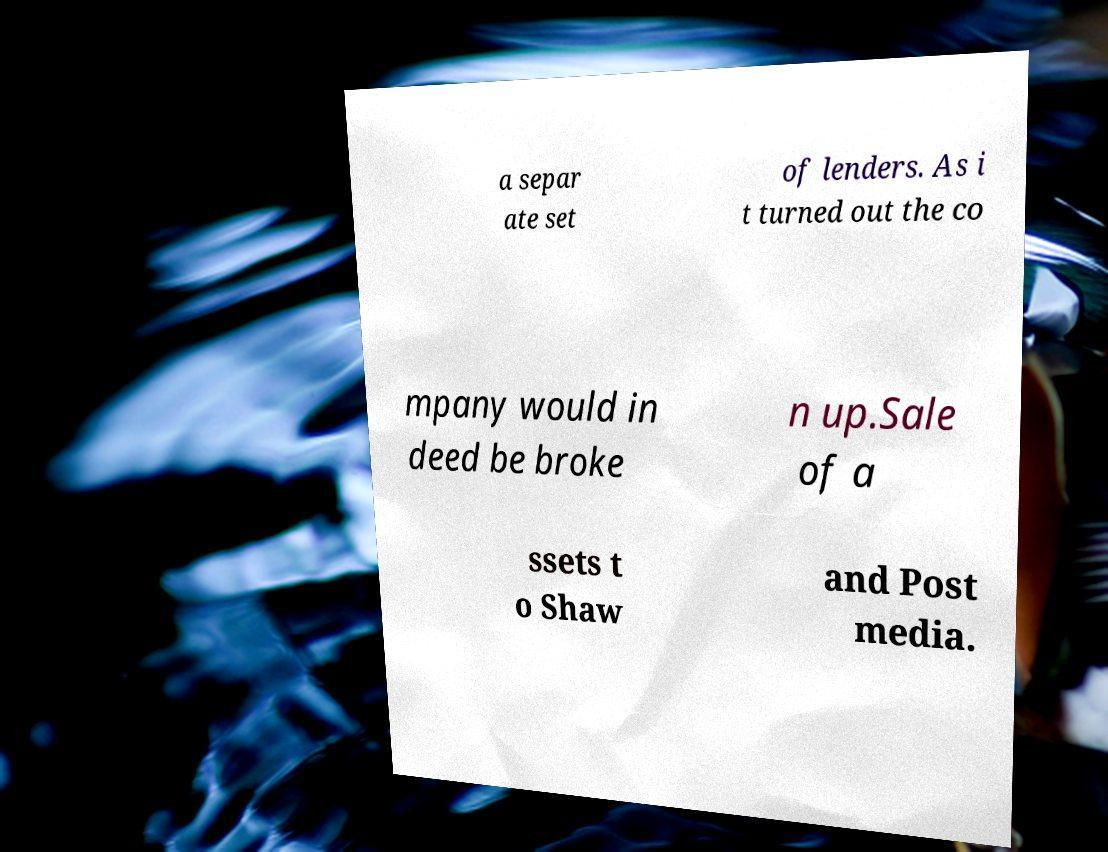For documentation purposes, I need the text within this image transcribed. Could you provide that? a separ ate set of lenders. As i t turned out the co mpany would in deed be broke n up.Sale of a ssets t o Shaw and Post media. 